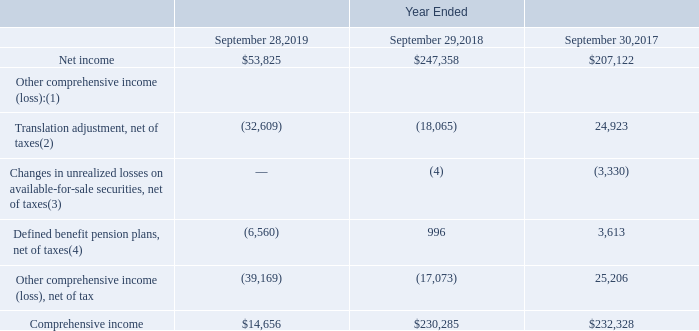COHERENT, INC. AND SUBSIDIARIES CONSOLIDATED STATEMENTS OF COMPREHENSIVE INCOME (In thousands)
(1) Reclassification adjustments were not significant during fiscal 2019, 2018 and 2017.
(2) Tax benefits of $(5,161), $0 and $(326) were provided on translation adjustments during fiscal 2019, 2018 and 2017, respectively.
(3) Tax benefits of $0, $(2) and $(1,876) were provided on changes in unrealized losses on available-for-sale securities during fiscal 2019, 2018 and 2017, respectively.
(4) Tax expenses (benefits) of $(2,371), $202 and $1,747 were provided on changes in defined benefit pension plans during fiscal 2019, 2018 and 2017, respectively.
What was Net income in 2019?
Answer scale should be: thousand. $53,825. What was  Comprehensive income  in 2018?
Answer scale should be: thousand. $230,285. In which years was Comprehensive income calculated? 2019, 2018, 2017. In which year was Comprehensive income largest? 232,328>230,285>14,656
Answer: 2017. What was the change in Net income in 2018 from 2017?
Answer scale should be: thousand. 247,358-207,122
Answer: 40236. What was the percentage change in Net income in 2018 from 2017?
Answer scale should be: percent. (247,358-207,122)/207,122
Answer: 19.43. 